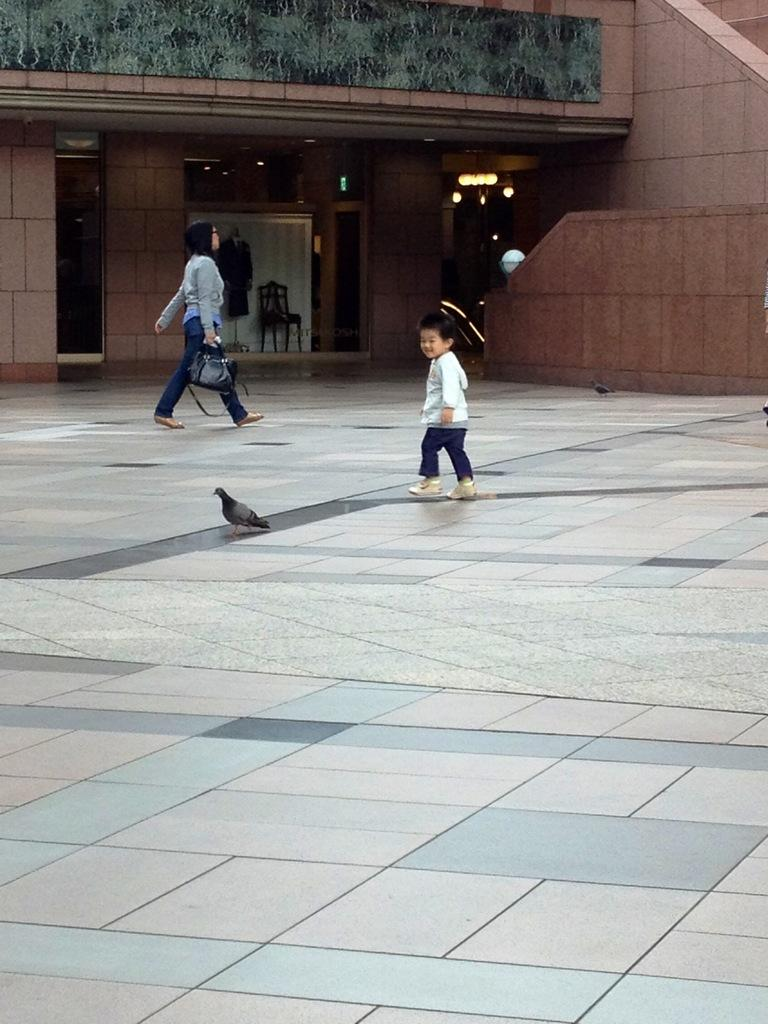What animal can be seen standing on the floor in the image? There is a pigeon standing on the floor in the image. What is the little boy doing in the image? The little boy is running in the image. What is the woman doing in the image? The woman is walking in the image. What is the woman wearing in the image? The woman is wearing a dress in the image. What object is the woman holding in the image? The woman is holding a handbag in the image. What effect does the nation have on the pigeon in the image? There is no mention of a nation in the image, and therefore no effect can be determined. How many hands does the pigeon have in the image? Pigeons do not have hands; they have wings and feet. 